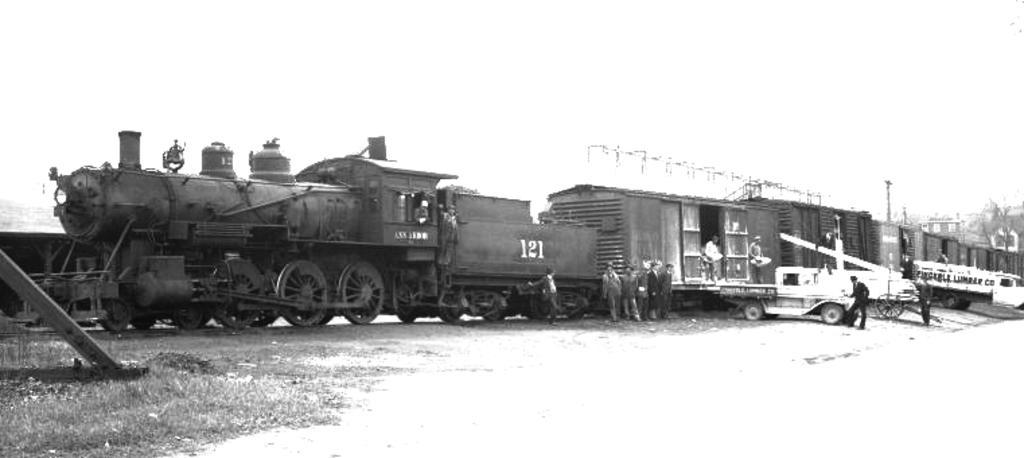Describe this image in one or two sentences. In this image there is a train, there are persons standing, there are vehicles, there is grass towards the left of the image, there is an object towards the left of the image, there is ground towards the bottom of the image, there is a pole, there are buildings towards the right of the image, there are trees towards the right of the image, the background of the image is white in color. 